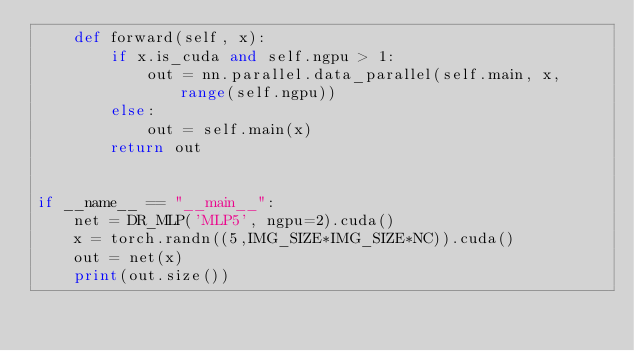<code> <loc_0><loc_0><loc_500><loc_500><_Python_>    def forward(self, x):
        if x.is_cuda and self.ngpu > 1:
            out = nn.parallel.data_parallel(self.main, x, range(self.ngpu))
        else:
            out = self.main(x)
        return out


if __name__ == "__main__":
    net = DR_MLP('MLP5', ngpu=2).cuda()
    x = torch.randn((5,IMG_SIZE*IMG_SIZE*NC)).cuda()
    out = net(x)
    print(out.size())
</code> 